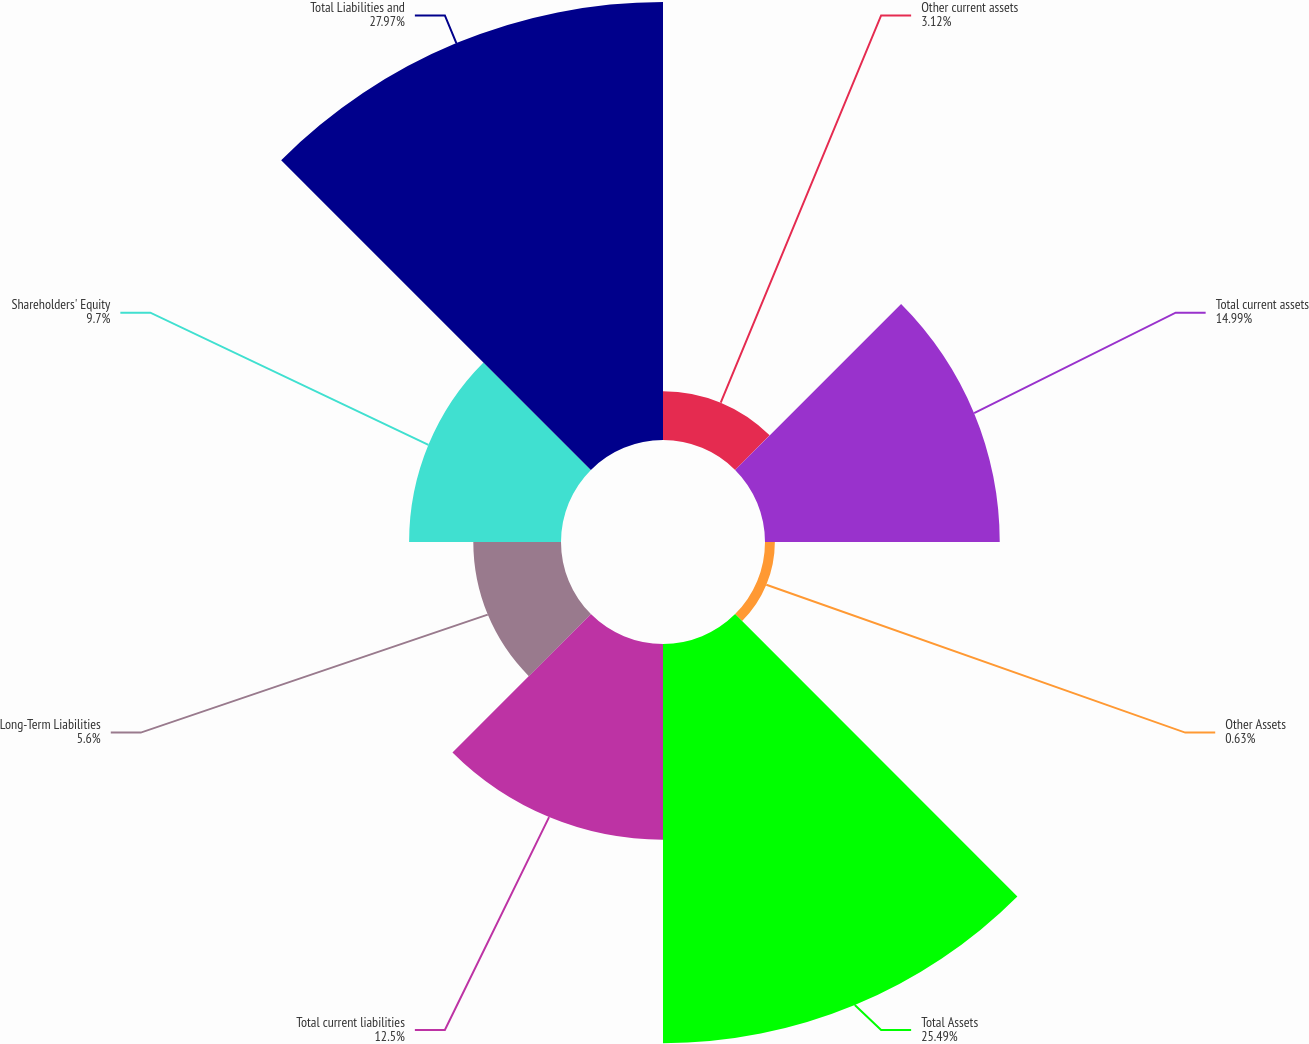Convert chart. <chart><loc_0><loc_0><loc_500><loc_500><pie_chart><fcel>Other current assets<fcel>Total current assets<fcel>Other Assets<fcel>Total Assets<fcel>Total current liabilities<fcel>Long-Term Liabilities<fcel>Shareholders' Equity<fcel>Total Liabilities and<nl><fcel>3.12%<fcel>14.99%<fcel>0.63%<fcel>25.49%<fcel>12.5%<fcel>5.6%<fcel>9.7%<fcel>27.97%<nl></chart> 